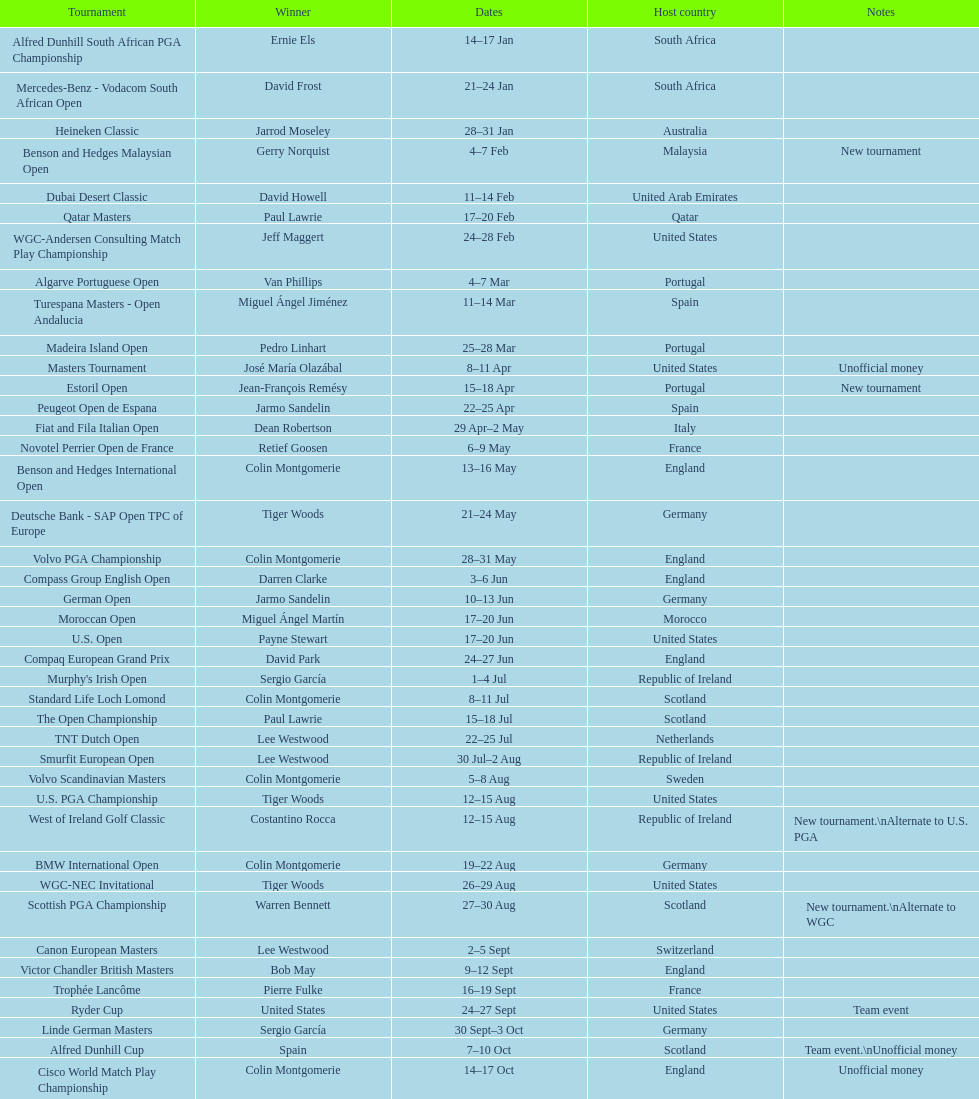Which tournament was later, volvo pga or algarve portuguese open? Volvo PGA. 